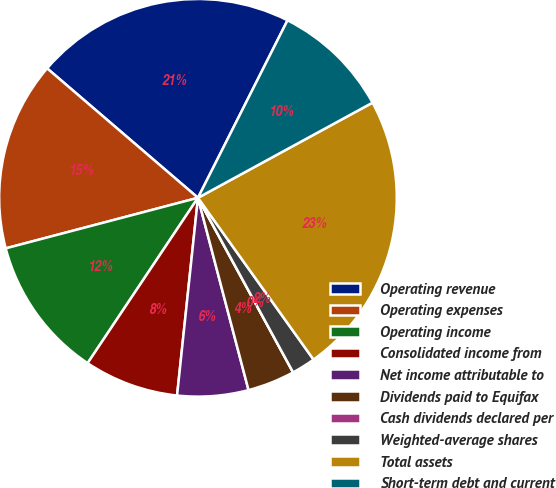Convert chart to OTSL. <chart><loc_0><loc_0><loc_500><loc_500><pie_chart><fcel>Operating revenue<fcel>Operating expenses<fcel>Operating income<fcel>Consolidated income from<fcel>Net income attributable to<fcel>Dividends paid to Equifax<fcel>Cash dividends declared per<fcel>Weighted-average shares<fcel>Total assets<fcel>Short-term debt and current<nl><fcel>21.15%<fcel>15.38%<fcel>11.54%<fcel>7.69%<fcel>5.77%<fcel>3.85%<fcel>0.0%<fcel>1.93%<fcel>23.07%<fcel>9.62%<nl></chart> 